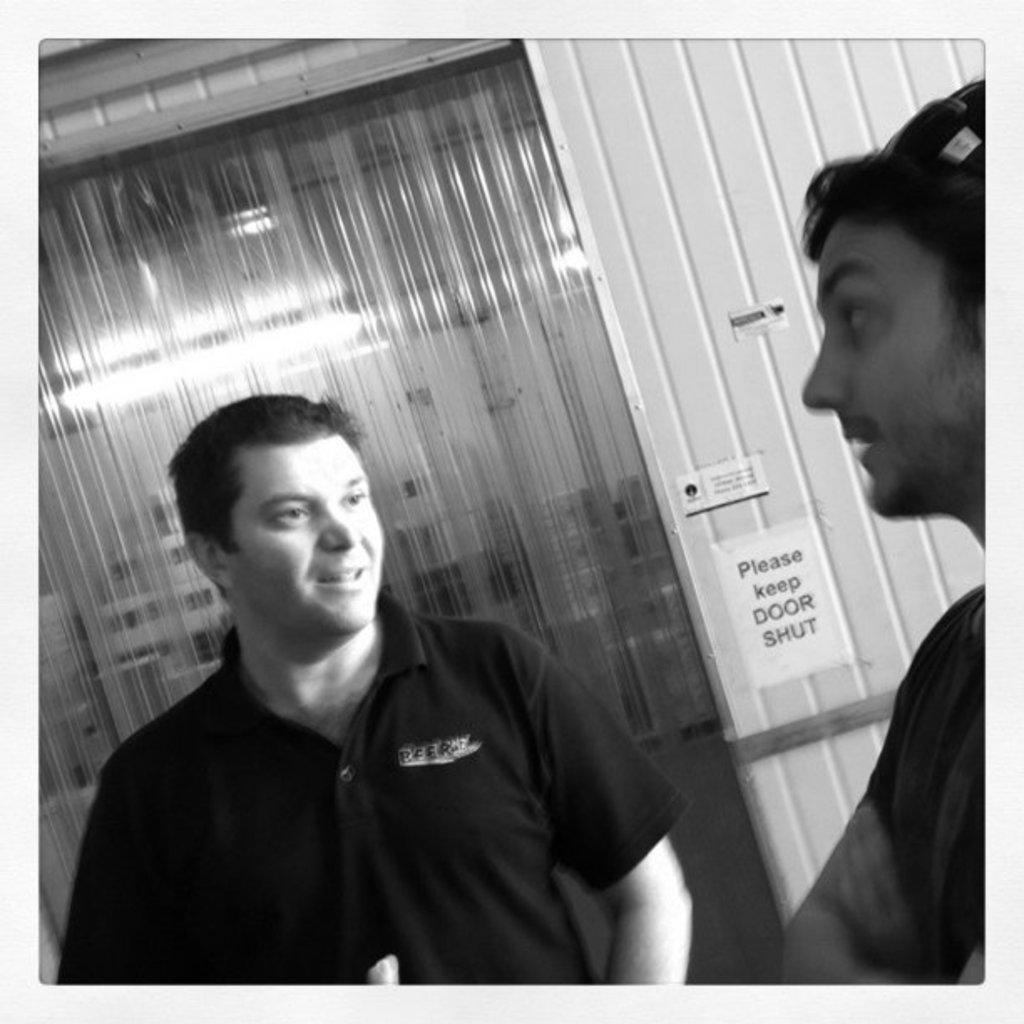Can you describe this image briefly? This is a black and white image. In the image there are two men standing. Behind them there is a wall with posters and also there is a door. 